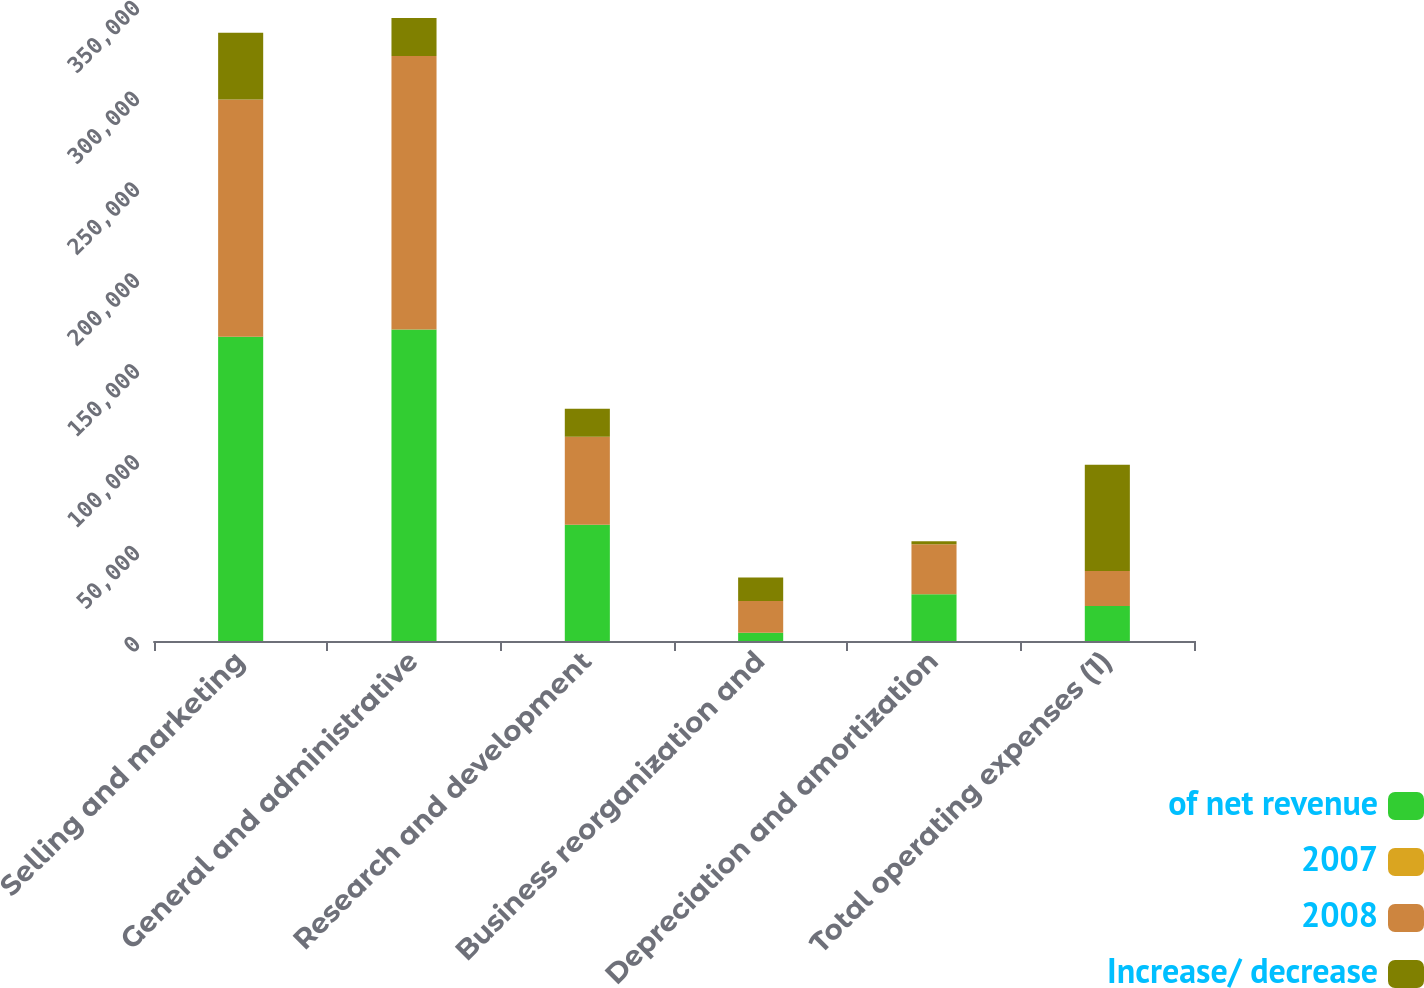<chart> <loc_0><loc_0><loc_500><loc_500><stacked_bar_chart><ecel><fcel>Selling and marketing<fcel>General and administrative<fcel>Research and development<fcel>Business reorganization and<fcel>Depreciation and amortization<fcel>Total operating expenses (1)<nl><fcel>of net revenue<fcel>167380<fcel>171440<fcel>63929<fcel>4478<fcel>25755<fcel>19237.5<nl><fcel>2007<fcel>10.9<fcel>11.2<fcel>4.2<fcel>0.3<fcel>1.7<fcel>28.2<nl><fcel>2008<fcel>130652<fcel>150432<fcel>48455<fcel>17467<fcel>27449<fcel>19237.5<nl><fcel>Increase/ decrease<fcel>36728<fcel>21008<fcel>15474<fcel>12989<fcel>1694<fcel>58527<nl></chart> 